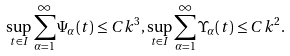Convert formula to latex. <formula><loc_0><loc_0><loc_500><loc_500>\sup _ { t \in I } \sum _ { \alpha = 1 } ^ { \infty } \Psi _ { \alpha } ( t ) \leq C k ^ { 3 } , \sup _ { t \in I } \sum _ { \alpha = 1 } ^ { \infty } \Upsilon _ { \alpha } ( t ) \leq C k ^ { 2 } .</formula> 